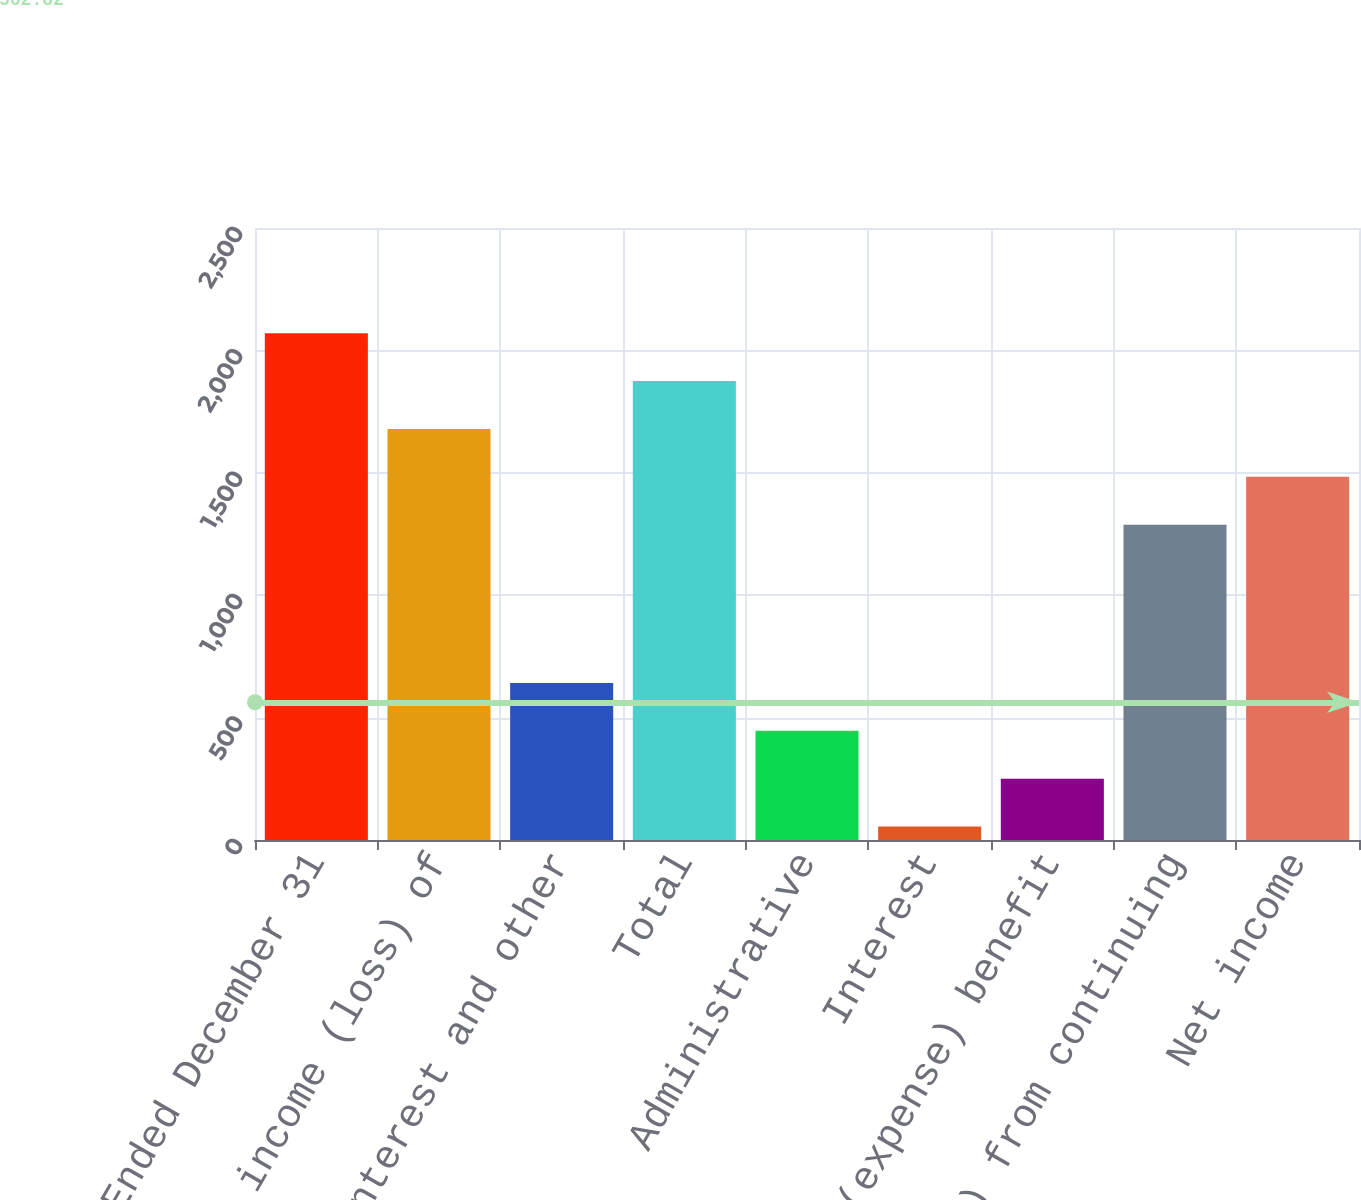Convert chart. <chart><loc_0><loc_0><loc_500><loc_500><bar_chart><fcel>Year Ended December 31<fcel>Equity in income (loss) of<fcel>Interest and other<fcel>Total<fcel>Administrative<fcel>Interest<fcel>Income tax (expense) benefit<fcel>Income (loss) from continuing<fcel>Net income<nl><fcel>2070<fcel>1679<fcel>641.5<fcel>1874.5<fcel>446<fcel>55<fcel>250.5<fcel>1288<fcel>1483.5<nl></chart> 